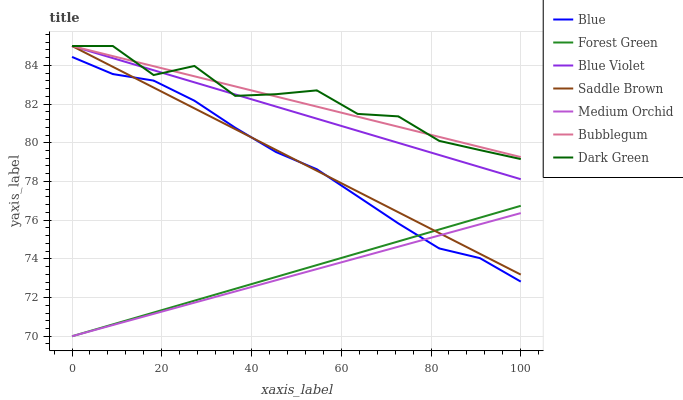Does Bubblegum have the minimum area under the curve?
Answer yes or no. No. Does Bubblegum have the maximum area under the curve?
Answer yes or no. No. Is Medium Orchid the smoothest?
Answer yes or no. No. Is Medium Orchid the roughest?
Answer yes or no. No. Does Bubblegum have the lowest value?
Answer yes or no. No. Does Medium Orchid have the highest value?
Answer yes or no. No. Is Medium Orchid less than Blue Violet?
Answer yes or no. Yes. Is Dark Green greater than Medium Orchid?
Answer yes or no. Yes. Does Medium Orchid intersect Blue Violet?
Answer yes or no. No. 